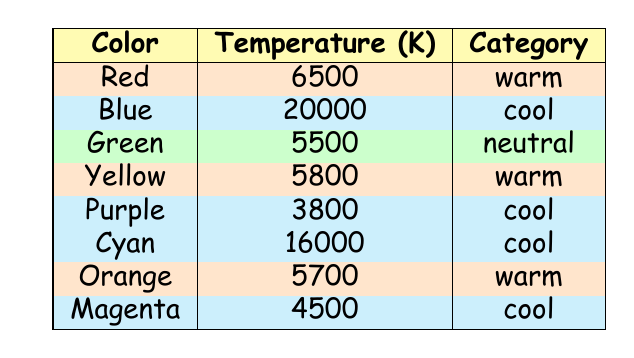What is the temperature of Blue? The table shows the color Blue has a temperature of 20000 K.
Answer: 20000 K Which colors are categorized as warm? The warm colors in the table are Red, Yellow, and Orange.
Answer: Red, Yellow, Orange What is the average temperature of the cool colors? The cool colors are Blue (20000 K), Purple (3800 K), Cyan (16000 K), and Magenta (4500 K). Adding these gives us (20000 + 3800 + 16000 + 4500) = 46300 K. There are 4 cool colors, so the average is 46300 / 4 = 11575 K.
Answer: 11575 K Is Green a cool color? According to the table, Green is categorized as a neutral color, not cool.
Answer: No Which color has the lowest temperature? Looking at the temperatures, Purple has the lowest value at 3800 K, as it's lower than all the other colors listed in the table.
Answer: Purple (3800 K) How many colors have a temperature greater than 6000 K? The colors with temperatures greater than 6000 K are Blue (20000 K), Red (6500 K), and Cyan (16000 K), which gives us a total of 4 colors: Blue, Red, Yellow, and Cyan.
Answer: 4 